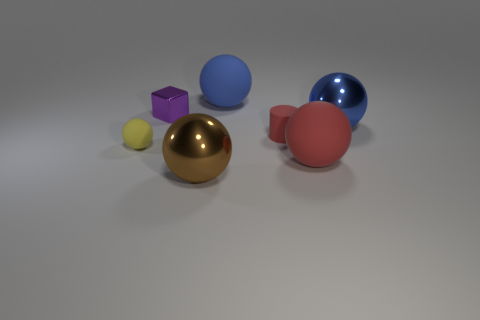Is there another object that has the same shape as the small red thing?
Offer a terse response. No. Do the small thing that is behind the tiny red cylinder and the small yellow object that is in front of the large blue metallic object have the same material?
Offer a very short reply. No. What number of big things are made of the same material as the large brown ball?
Your answer should be very brief. 1. The matte cylinder has what color?
Offer a terse response. Red. There is a metallic object in front of the tiny yellow rubber ball; does it have the same shape as the large rubber object behind the purple object?
Provide a short and direct response. Yes. What color is the metallic object that is in front of the yellow matte ball?
Make the answer very short. Brown. Are there fewer tiny objects that are behind the cube than tiny shiny cubes to the right of the big brown metallic sphere?
Make the answer very short. No. What number of other things are made of the same material as the large red thing?
Keep it short and to the point. 3. Does the large brown thing have the same material as the small sphere?
Ensure brevity in your answer.  No. How many other objects are there of the same size as the brown object?
Offer a very short reply. 3. 